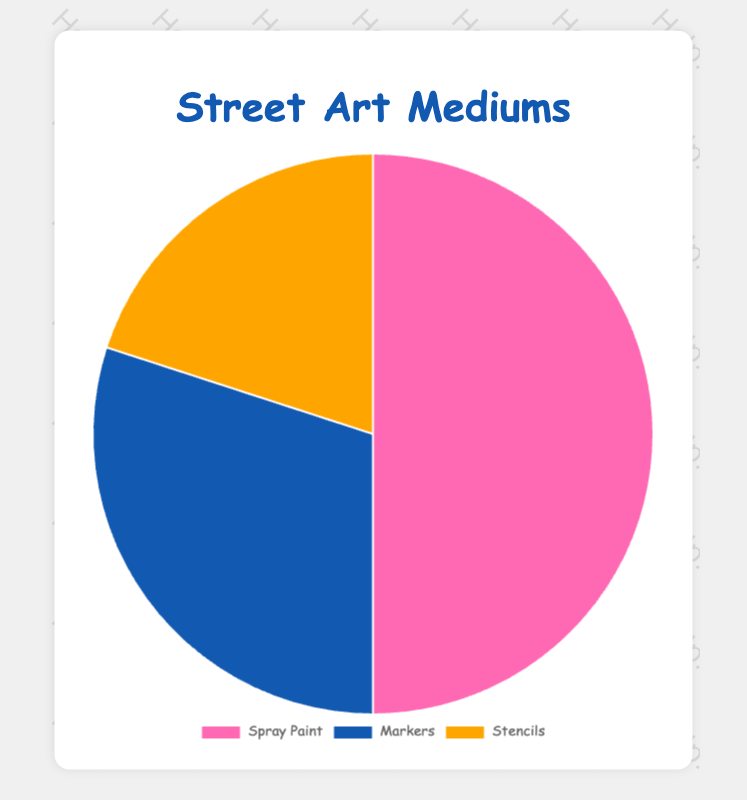Which street art medium is the most commonly used? The figure shows that Spray Paint has the largest section in the pie chart with a 50% share.
Answer: Spray Paint Which medium is the least used according to the chart? Stencils have the smallest section in the pie chart with a 20% share.
Answer: Stencils How much more popular is Spray Paint compared to Markers? Spray Paint has a 50% share, while Markers have a 30% share. The difference between them is 50% - 30%.
Answer: 20% What is the combined percentage of Markers and Stencils? Markers have a 30% share, and Stencils have a 20% share. Adding these together is 30% + 20%.
Answer: 50% What proportion of the pie chart is represented by mediums other than Spray Paint? Markers and Stencils together represent the part other than Spray Paint, which is 30% + 20%.
Answer: 50% Are Spray Paint and Markers together more than half of the pie chart? Spray Paint is 50% and Markers is 30%, so together they make up 80%, which is more than half.
Answer: Yes Which medium has a section colored in pink? By visual inspection, the section colored in pink represents Spray Paint.
Answer: Spray Paint If Stencils usage were to double, what would its new percentage be and would it be the largest section? Doubling Stencils would result in 20% * 2 = 40%. It still would not be the largest section since Spray Paint is 50%.
Answer: 40%, No What is the average percentage share of all three mediums? The sum of all percentages (50% + 30% + 20%) is 100%. The average is 100% / 3.
Answer: 33.33% What is the difference in percentage between the least used and the most used mediums? The most used is Spray Paint at 50%, and the least used is Stencils at 20%. The difference is 50% - 20%.
Answer: 30% 